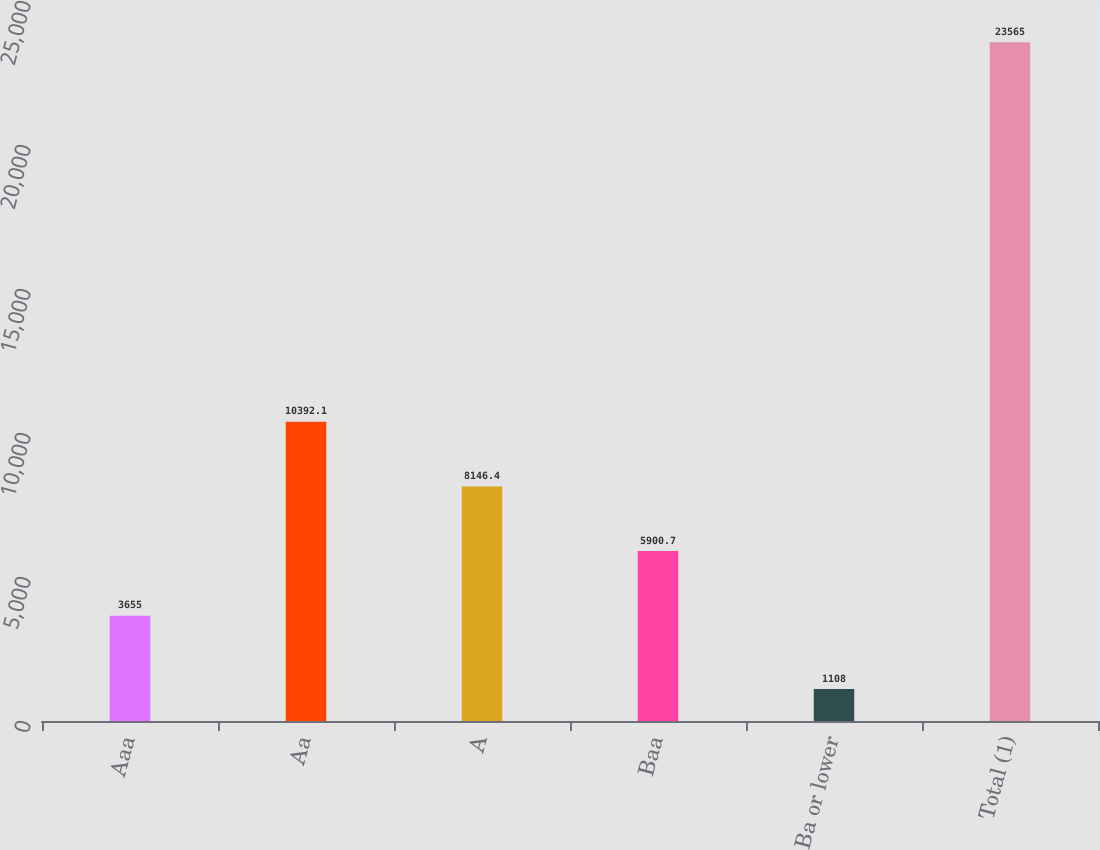Convert chart to OTSL. <chart><loc_0><loc_0><loc_500><loc_500><bar_chart><fcel>Aaa<fcel>Aa<fcel>A<fcel>Baa<fcel>Ba or lower<fcel>Total (1)<nl><fcel>3655<fcel>10392.1<fcel>8146.4<fcel>5900.7<fcel>1108<fcel>23565<nl></chart> 